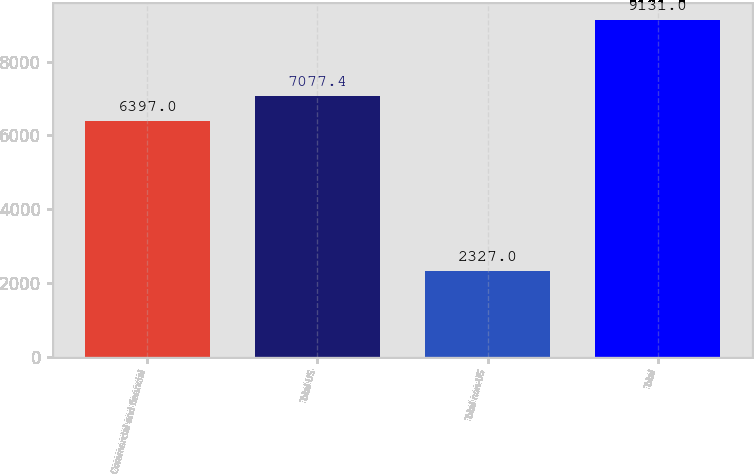Convert chart to OTSL. <chart><loc_0><loc_0><loc_500><loc_500><bar_chart><fcel>Commercial and financial<fcel>Total US<fcel>Total non-US<fcel>Total<nl><fcel>6397<fcel>7077.4<fcel>2327<fcel>9131<nl></chart> 